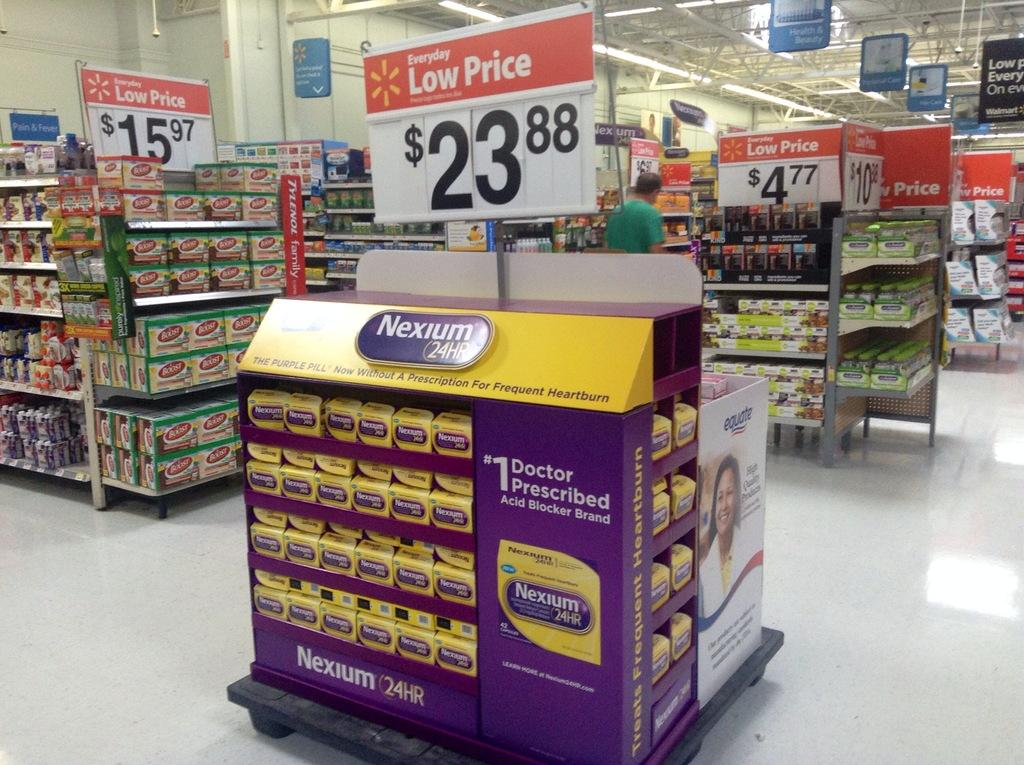<image>
Share a concise interpretation of the image provided. Signs in a store that claim low prices. 